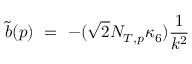<formula> <loc_0><loc_0><loc_500><loc_500>\tilde { b } ( p ) \ = \ - ( \sqrt { 2 } N _ { T , p } \kappa _ { 6 } ) \frac { 1 } { k ^ { 2 } }</formula> 